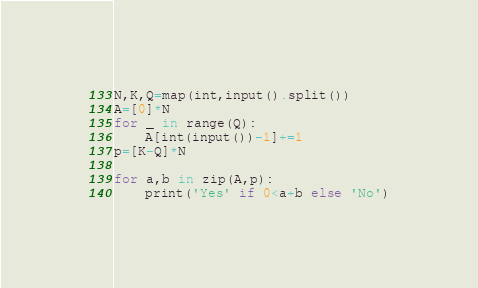Convert code to text. <code><loc_0><loc_0><loc_500><loc_500><_Python_>N,K,Q=map(int,input().split())
A=[0]*N
for _ in range(Q):
    A[int(input())-1]+=1
p=[K-Q]*N

for a,b in zip(A,p):
    print('Yes' if 0<a+b else 'No')</code> 